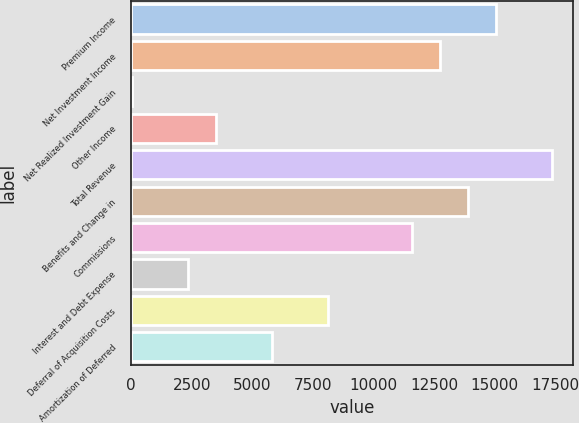<chart> <loc_0><loc_0><loc_500><loc_500><bar_chart><fcel>Premium Income<fcel>Net Investment Income<fcel>Net Realized Investment Gain<fcel>Other Income<fcel>Total Revenue<fcel>Benefits and Change in<fcel>Commissions<fcel>Interest and Debt Expense<fcel>Deferral of Acquisition Costs<fcel>Amortization of Deferred<nl><fcel>15066.2<fcel>12754.4<fcel>39.5<fcel>3507.2<fcel>17378<fcel>13910.3<fcel>11598.5<fcel>2351.3<fcel>8130.8<fcel>5819<nl></chart> 